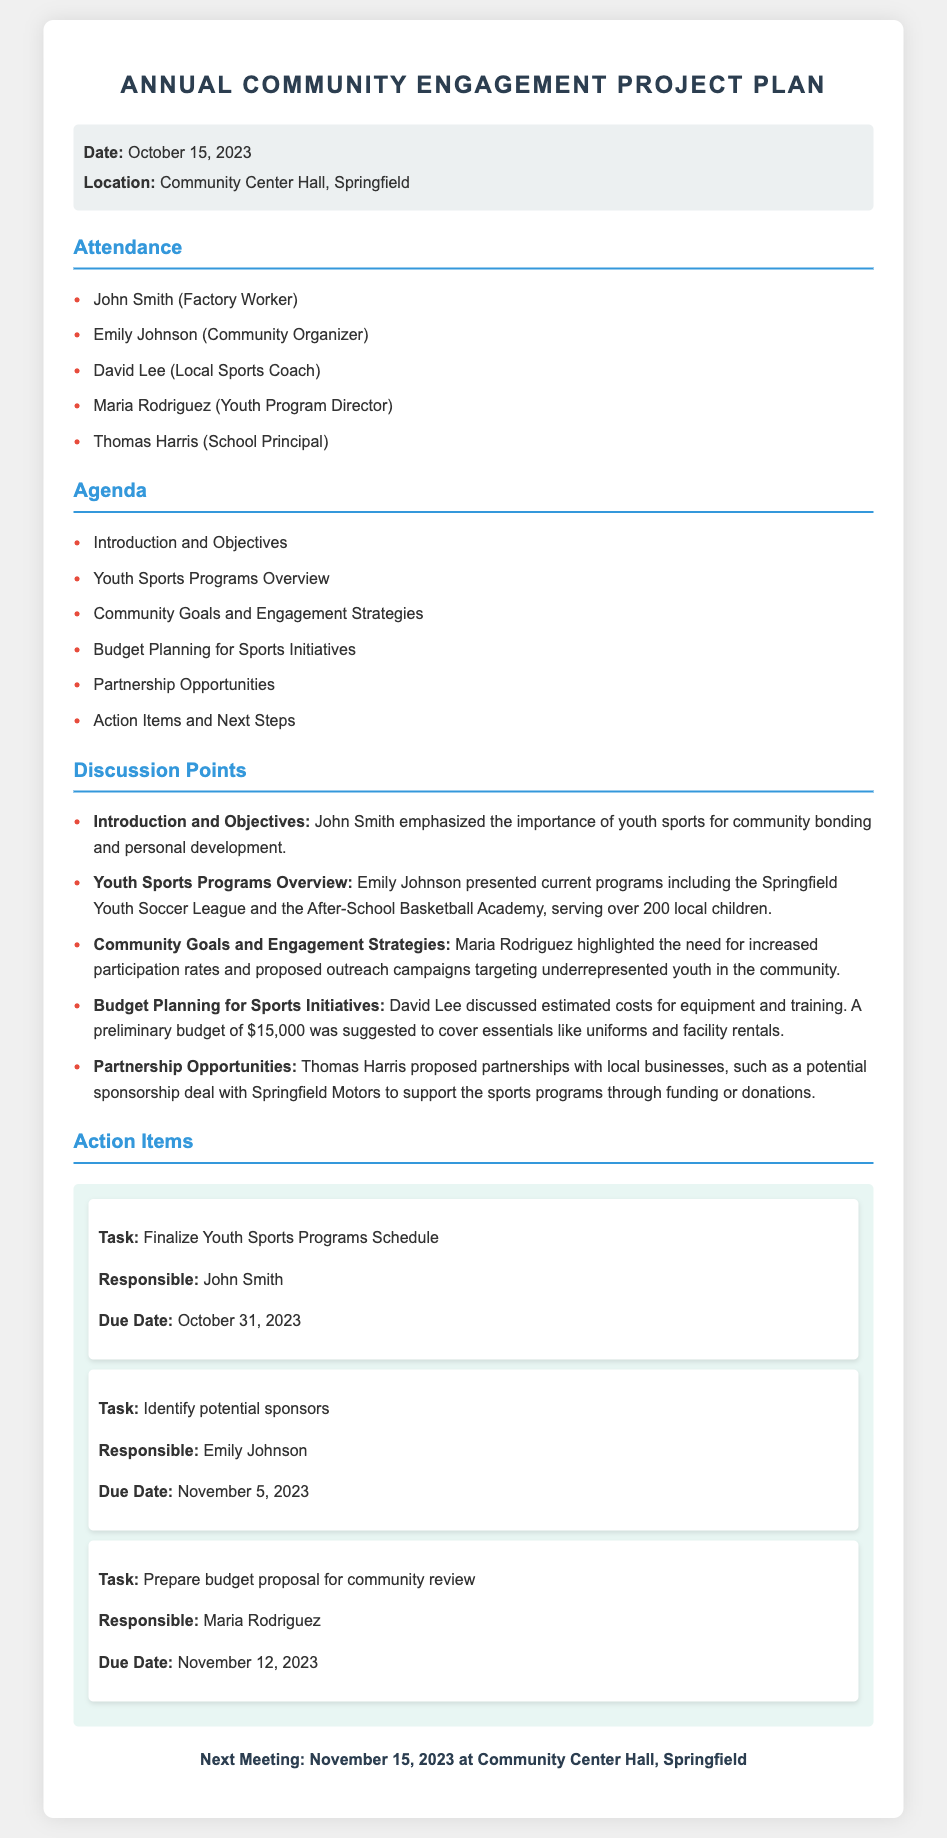What is the date of the meeting? The date of the meeting is stated in the meta-info section of the document.
Answer: October 15, 2023 Who is the responsible person for finalizing the Youth Sports Programs Schedule? The responsible person is listed in the action items section of the document.
Answer: John Smith What is the estimated budget for sports initiatives? The estimated budget is provided during the budget planning discussion in the document.
Answer: $15,000 Which sports programs serve over 200 local children? The specific programs are mentioned in the overview of youth sports programs.
Answer: Springfield Youth Soccer League and the After-School Basketball Academy When is the next meeting scheduled? The next meeting date is included at the end of the document.
Answer: November 15, 2023 What did Maria Rodriguez highlight as a community goal? The point made by Maria Rodriguez regarding community goals is recorded in the discussion points section.
Answer: Increased participation rates Who proposed partnerships with local businesses? This information can be found in the discussion points related to partnership opportunities.
Answer: Thomas Harris What is the due date for identifying potential sponsors? The due date for the task is specified in the action items section.
Answer: November 5, 2023 What theme does the introduction emphasize? The theme of the introduction is articulated in the introduction and objectives part of the discussion.
Answer: Importance of youth sports 